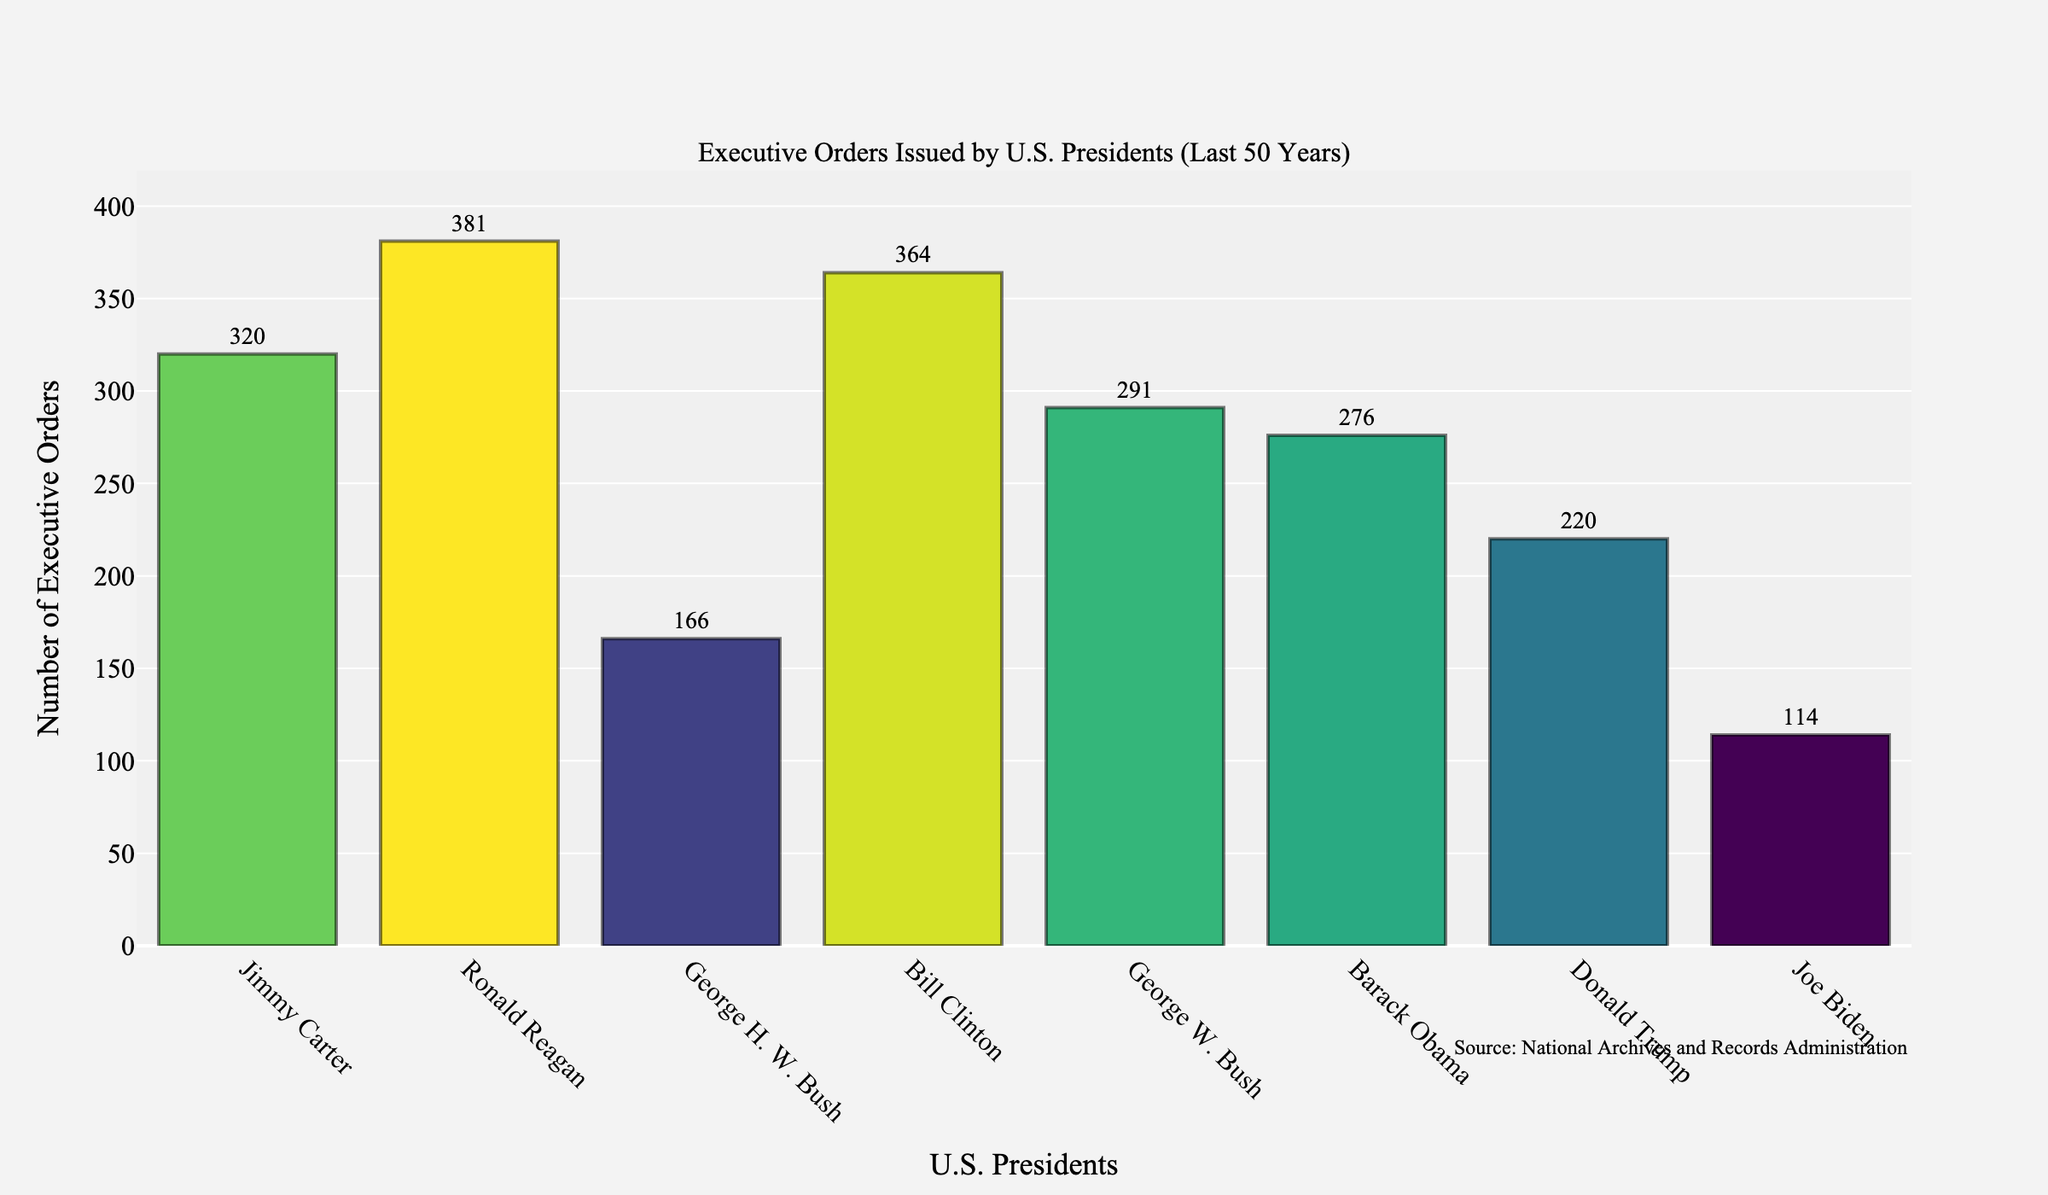Which president issued the highest number of executive orders? Bill Clinton issued 364 executive orders, which is the highest among the presidents listed in the figure.
Answer: Bill Clinton Which president issued the least number of executive orders? Joe Biden issued 114 executive orders, which is the lowest among the presidents listed in the figure.
Answer: Joe Biden How many more executive orders did Ronald Reagan issue compared to Barack Obama? Ronald Reagan issued 381 executive orders, while Barack Obama issued 276. The difference is 381 - 276 = 105.
Answer: 105 What is the total number of executive orders issued by presidents who served two terms? The presidents who served two terms are Ronald Reagan, Bill Clinton, George W. Bush, and Barack Obama. Summing their executive orders: 381 + 364 + 291 + 276 = 1,312.
Answer: 1,312 Which presidents issued more than 300 executive orders? The presidents who issued more than 300 executive orders are Jimmy Carter, Ronald Reagan, and Bill Clinton, with totals of 320, 381, and 364 respectively.
Answer: Jimmy Carter, Ronald Reagan, Bill Clinton How many executive orders did George W. Bush and Donald Trump issue combined? George W. Bush issued 291 executive orders, and Donald Trump issued 220. The combined total is 291 + 220 = 511.
Answer: 511 Among the presidents listed, who issued fewer executive orders: George H. W. Bush or Joe Biden? Joe Biden issued fewer executive orders (114) compared to George H. W. Bush (166).
Answer: Joe Biden What is the average number of executive orders issued by the presidents in the chart? The total number of executive orders issued by all presidents is 320 + 381 + 166 + 364 + 291 + 276 + 220 + 114 = 2,132. There are 8 presidents, so the average is 2,132 / 8 = 266.5.
Answer: 266.5 What is the difference in the number of executive orders between the president with the highest number and the one with the lowest number? Bill Clinton issued 364 executive orders (the highest), and Joe Biden issued 114 (the lowest). The difference is 364 - 114 = 250.
Answer: 250 How many fewer executive orders did Barack Obama issue compared to Bill Clinton? Bill Clinton issued 364 executive orders, and Barack Obama issued 276. The difference is 364 - 276 = 88.
Answer: 88 